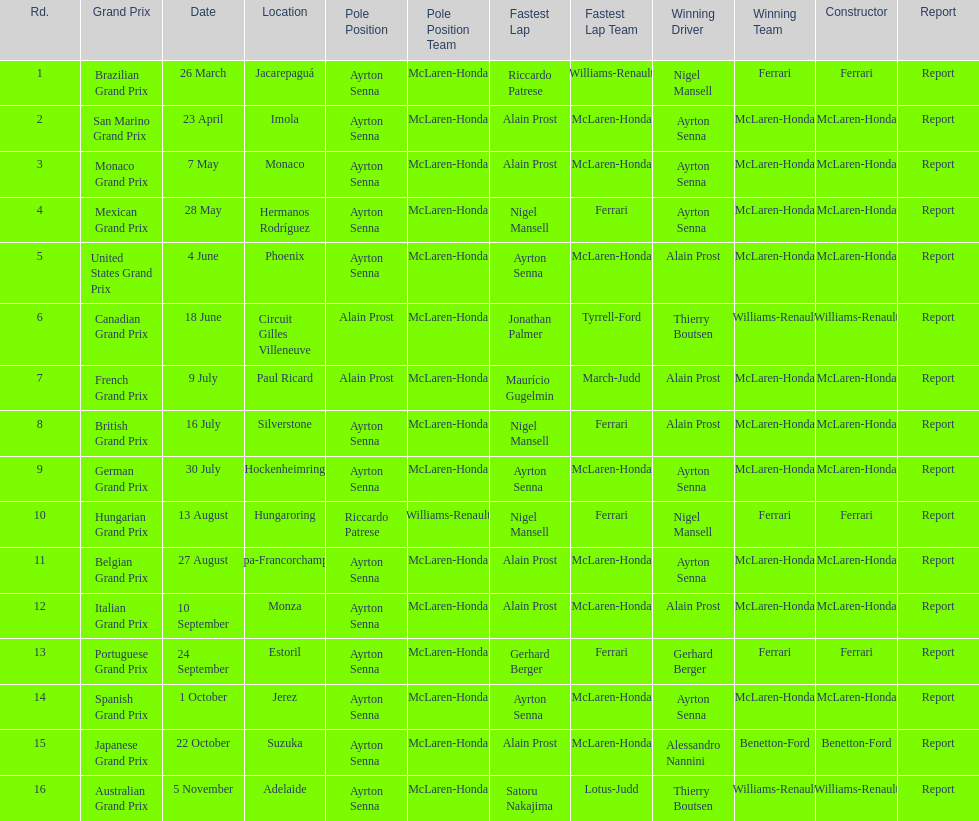Could you parse the entire table? {'header': ['Rd.', 'Grand Prix', 'Date', 'Location', 'Pole Position', 'Pole Position Team', 'Fastest Lap', 'Fastest Lap Team', 'Winning Driver', 'Winning Team', 'Constructor', 'Report'], 'rows': [['1', 'Brazilian Grand Prix', '26 March', 'Jacarepaguá', 'Ayrton Senna', 'McLaren-Honda', 'Riccardo Patrese', 'Williams-Renault', 'Nigel Mansell', 'Ferrari', 'Ferrari', 'Report'], ['2', 'San Marino Grand Prix', '23 April', 'Imola', 'Ayrton Senna', 'McLaren-Honda', 'Alain Prost', 'McLaren-Honda', 'Ayrton Senna', 'McLaren-Honda', 'McLaren-Honda', 'Report'], ['3', 'Monaco Grand Prix', '7 May', 'Monaco', 'Ayrton Senna', 'McLaren-Honda', 'Alain Prost', 'McLaren-Honda', 'Ayrton Senna', 'McLaren-Honda', 'McLaren-Honda', 'Report'], ['4', 'Mexican Grand Prix', '28 May', 'Hermanos Rodríguez', 'Ayrton Senna', 'McLaren-Honda', 'Nigel Mansell', 'Ferrari', 'Ayrton Senna', 'McLaren-Honda', 'McLaren-Honda', 'Report'], ['5', 'United States Grand Prix', '4 June', 'Phoenix', 'Ayrton Senna', 'McLaren-Honda', 'Ayrton Senna', 'McLaren-Honda', 'Alain Prost', 'McLaren-Honda', 'McLaren-Honda', 'Report'], ['6', 'Canadian Grand Prix', '18 June', 'Circuit Gilles Villeneuve', 'Alain Prost', 'McLaren-Honda', 'Jonathan Palmer', 'Tyrrell-Ford', 'Thierry Boutsen', 'Williams-Renault', 'Williams-Renault', 'Report'], ['7', 'French Grand Prix', '9 July', 'Paul Ricard', 'Alain Prost', 'McLaren-Honda', 'Maurício Gugelmin', 'March-Judd', 'Alain Prost', 'McLaren-Honda', 'McLaren-Honda', 'Report'], ['8', 'British Grand Prix', '16 July', 'Silverstone', 'Ayrton Senna', 'McLaren-Honda', 'Nigel Mansell', 'Ferrari', 'Alain Prost', 'McLaren-Honda', 'McLaren-Honda', 'Report'], ['9', 'German Grand Prix', '30 July', 'Hockenheimring', 'Ayrton Senna', 'McLaren-Honda', 'Ayrton Senna', 'McLaren-Honda', 'Ayrton Senna', 'McLaren-Honda', 'McLaren-Honda', 'Report'], ['10', 'Hungarian Grand Prix', '13 August', 'Hungaroring', 'Riccardo Patrese', 'Williams-Renault', 'Nigel Mansell', 'Ferrari', 'Nigel Mansell', 'Ferrari', 'Ferrari', 'Report'], ['11', 'Belgian Grand Prix', '27 August', 'Spa-Francorchamps', 'Ayrton Senna', 'McLaren-Honda', 'Alain Prost', 'McLaren-Honda', 'Ayrton Senna', 'McLaren-Honda', 'McLaren-Honda', 'Report'], ['12', 'Italian Grand Prix', '10 September', 'Monza', 'Ayrton Senna', 'McLaren-Honda', 'Alain Prost', 'McLaren-Honda', 'Alain Prost', 'McLaren-Honda', 'McLaren-Honda', 'Report'], ['13', 'Portuguese Grand Prix', '24 September', 'Estoril', 'Ayrton Senna', 'McLaren-Honda', 'Gerhard Berger', 'Ferrari', 'Gerhard Berger', 'Ferrari', 'Ferrari', 'Report'], ['14', 'Spanish Grand Prix', '1 October', 'Jerez', 'Ayrton Senna', 'McLaren-Honda', 'Ayrton Senna', 'McLaren-Honda', 'Ayrton Senna', 'McLaren-Honda', 'McLaren-Honda', 'Report'], ['15', 'Japanese Grand Prix', '22 October', 'Suzuka', 'Ayrton Senna', 'McLaren-Honda', 'Alain Prost', 'McLaren-Honda', 'Alessandro Nannini', 'Benetton-Ford', 'Benetton-Ford', 'Report'], ['16', 'Australian Grand Prix', '5 November', 'Adelaide', 'Ayrton Senna', 'McLaren-Honda', 'Satoru Nakajima', 'Lotus-Judd', 'Thierry Boutsen', 'Williams-Renault', 'Williams-Renault', 'Report']]} Before the san marino grand prix, which grand prix was held? Brazilian Grand Prix. 